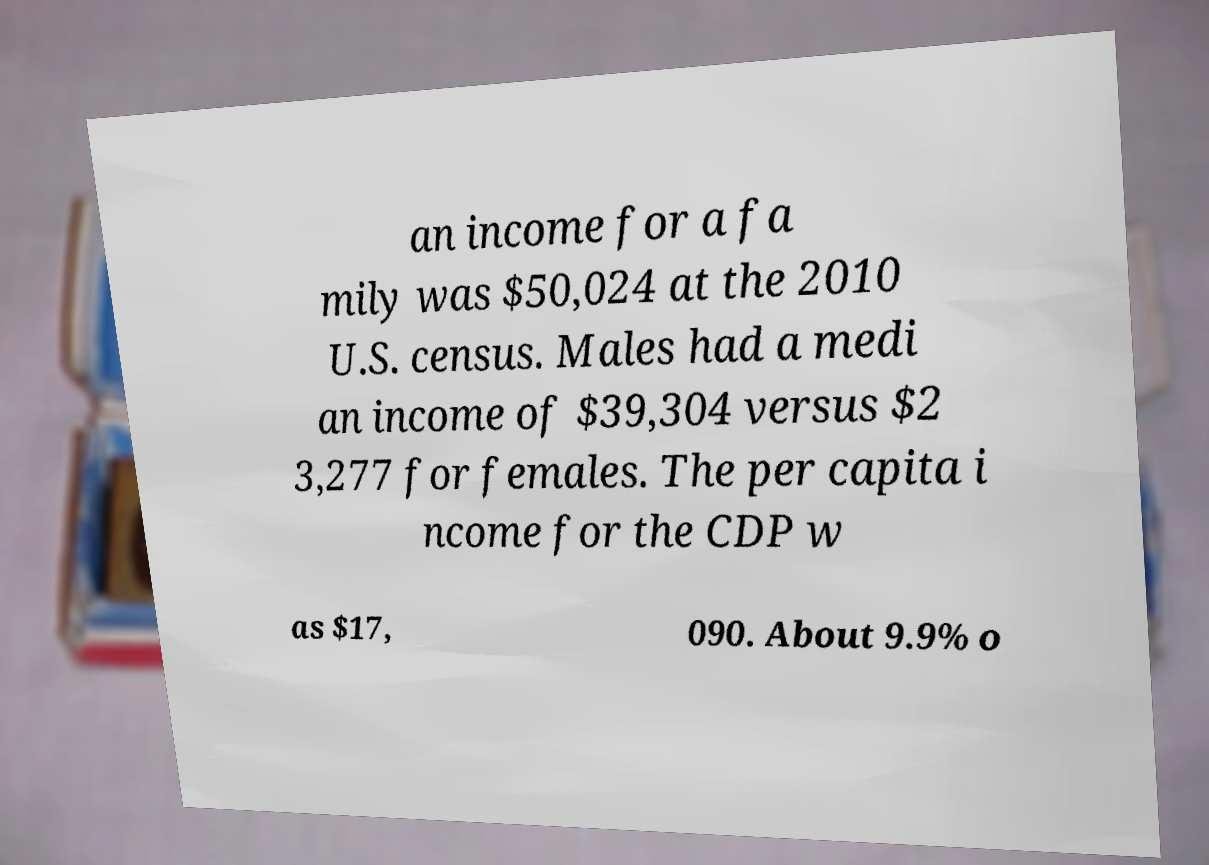Can you read and provide the text displayed in the image?This photo seems to have some interesting text. Can you extract and type it out for me? an income for a fa mily was $50,024 at the 2010 U.S. census. Males had a medi an income of $39,304 versus $2 3,277 for females. The per capita i ncome for the CDP w as $17, 090. About 9.9% o 